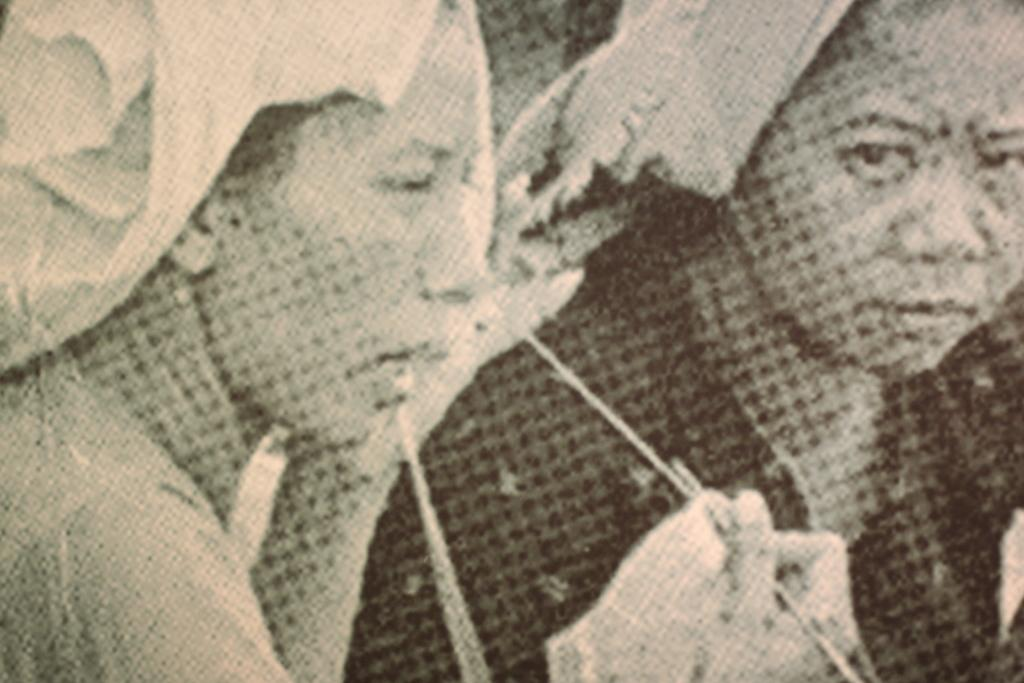How many individuals are present in the image? There are two people in the image. What type of wool is being used for the business transaction in the image? There is no wool or business transaction present in the image; it only features two people. 